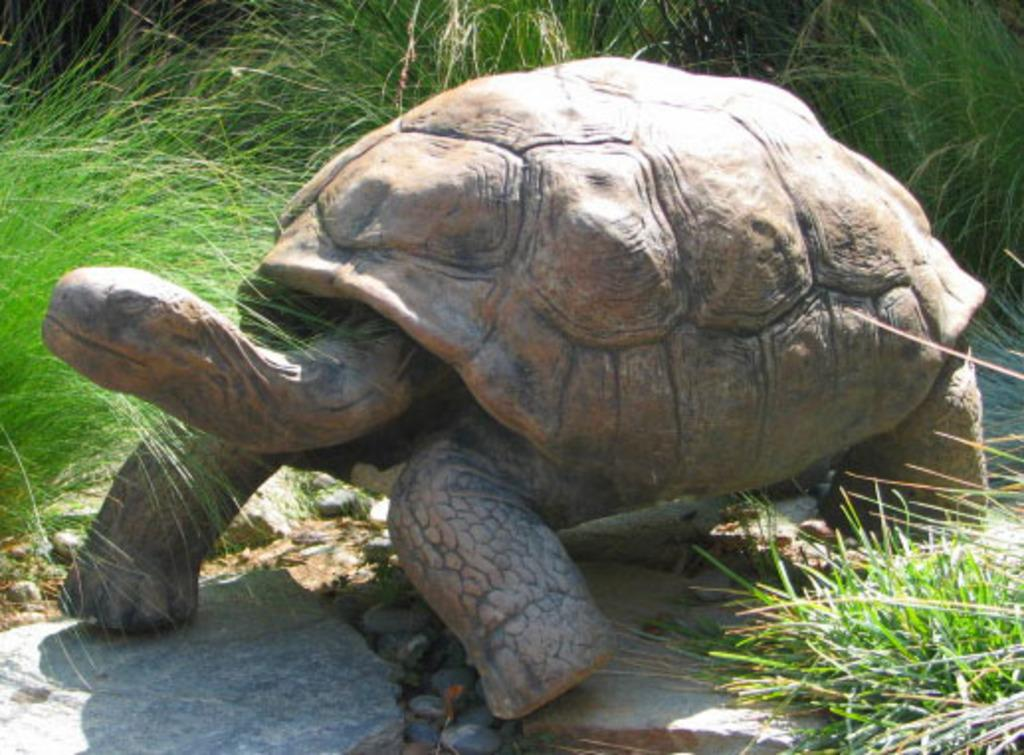What animal can be seen in the picture? There is a tortoise in the picture. Where is the tortoise located in relation to the grass? The tortoise is standing near the grass. What type of terrain is visible at the bottom of the image? There are stones visible at the bottom of the image. What type of glove is the tortoise wearing on its wrist in the image? There is no glove or wrist visible on the tortoise in the image; it is a tortoise without any clothing or accessories. 